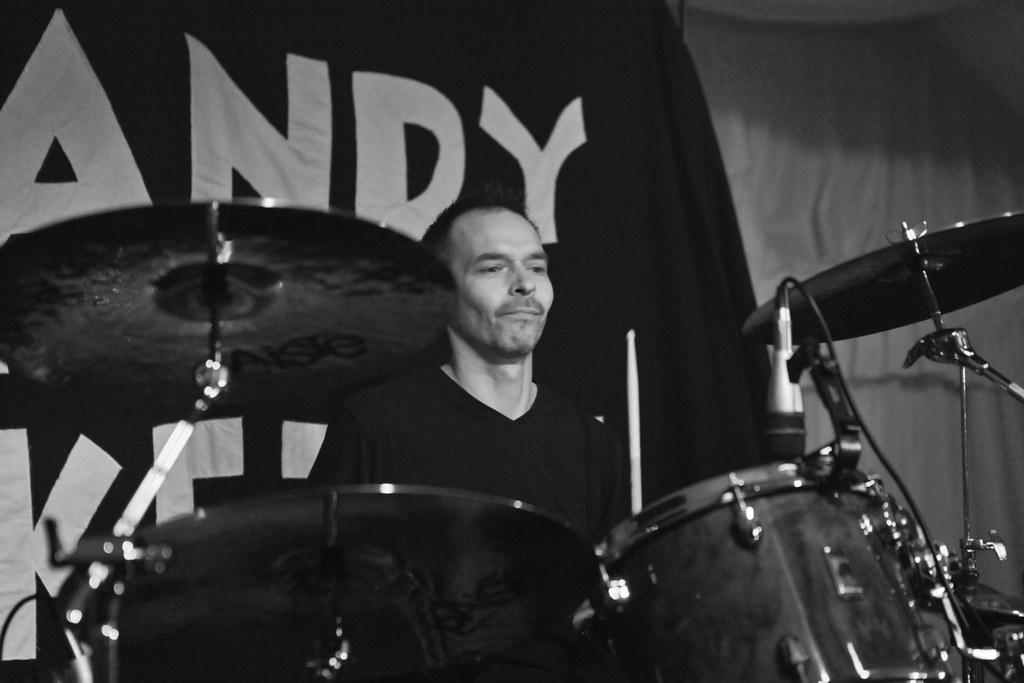What is located at the bottom of the image? There are drums at the bottom of the image. Who is positioned near the drums? A person is sitting behind the drums. What can be seen behind the person? There is a banner behind the person. What type of tent is visible in the image? There is no tent present in the image. What effect does the cloud have on the person playing the drums? There is no cloud present in the image, so it cannot have any effect on the person playing the drums. 